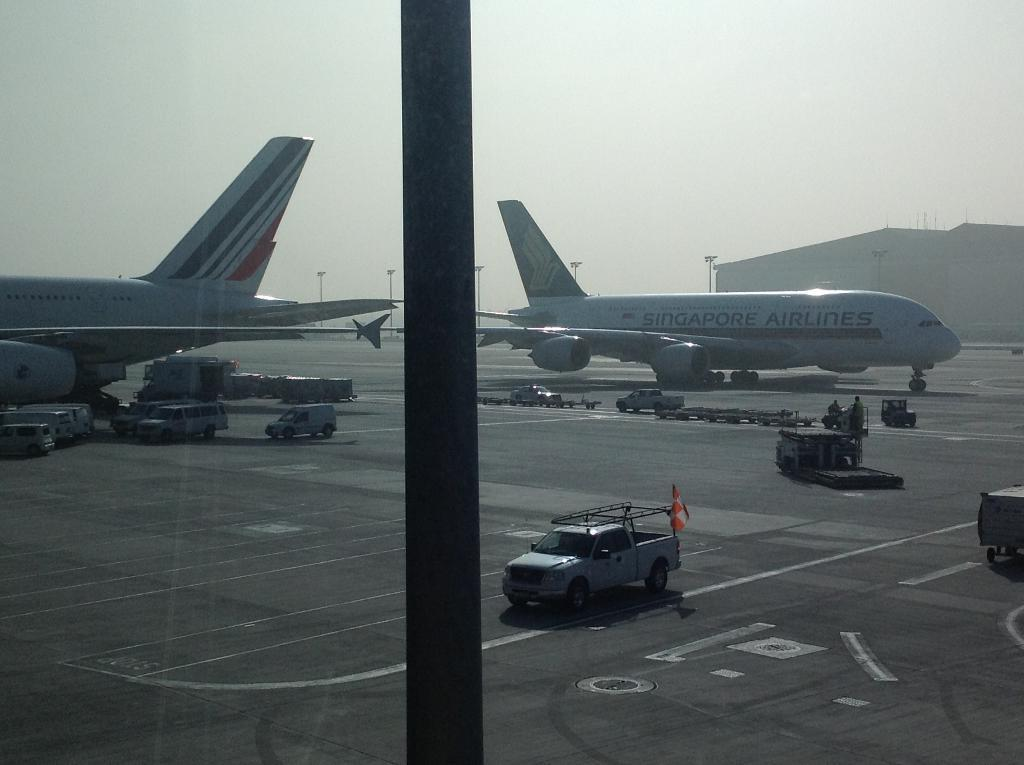What can be seen on both sides of the image? There are aeroplanes on both the right and left sides of the image. What is located in the center of the image? There are vans in the center of the image. What is visible in the background of the image? There are poles in the background area of the image. What type of square object can be seen in the image? There is no square object present in the image. What kind of pipe is visible in the image? There is no pipe visible in the image. 